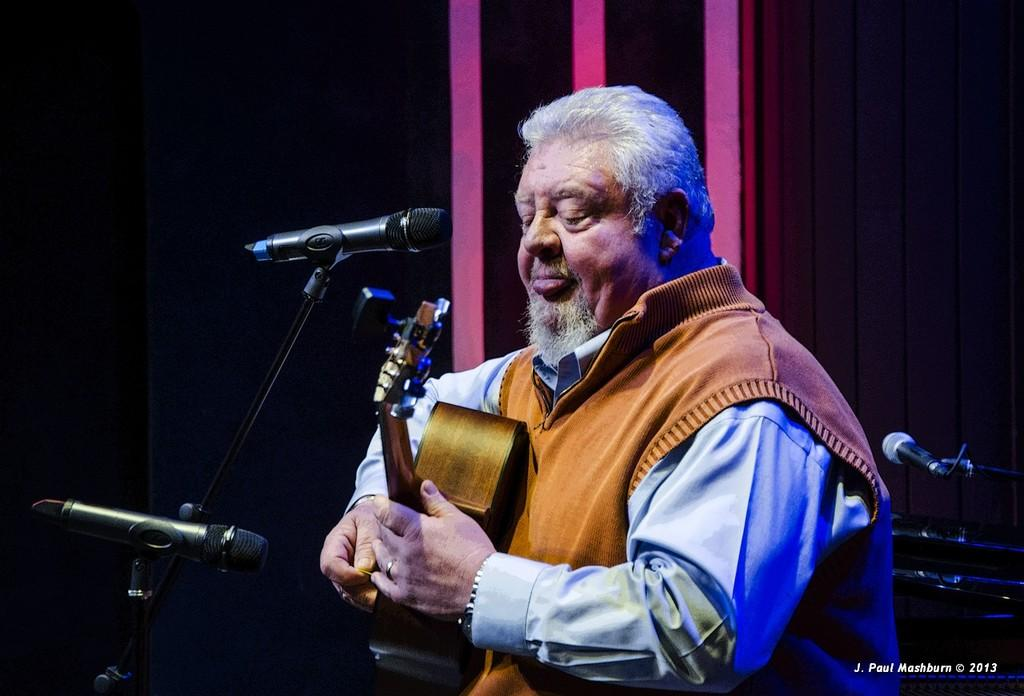Who is the main subject in the image? There is a woman in the image. What is the woman doing in the image? The woman is standing at a mic and holding a guitar. What can be seen in the background of the image? There is a wall in the background of the image. What type of chalk is the woman using to draw on the wall in the image? There is no chalk or drawing on the wall in the image. What kind of fruit is the woman holding in her other hand in the image? The woman is only holding a guitar in the image, and there is no fruit present. 